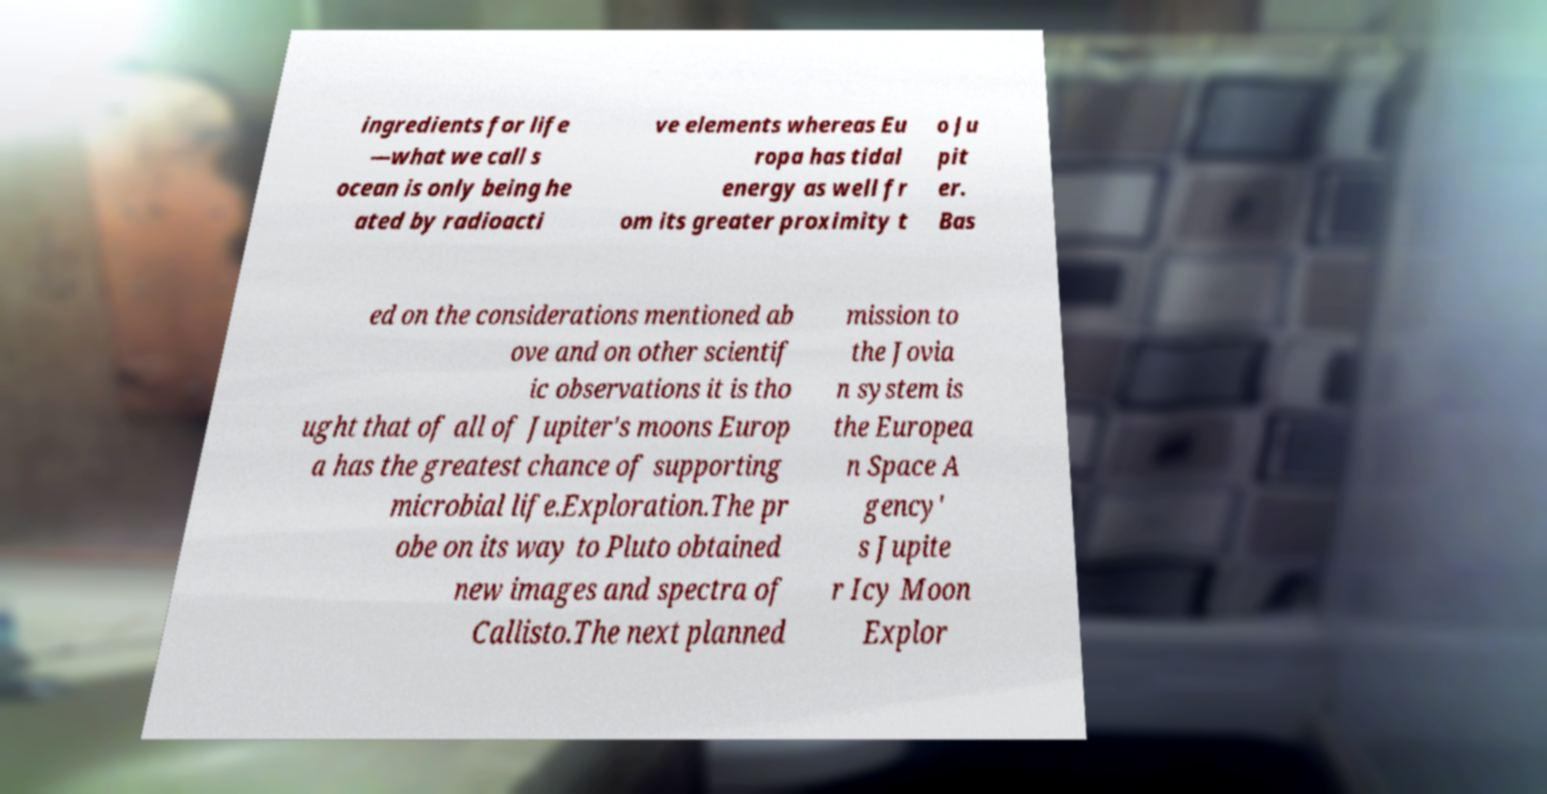There's text embedded in this image that I need extracted. Can you transcribe it verbatim? ingredients for life —what we call s ocean is only being he ated by radioacti ve elements whereas Eu ropa has tidal energy as well fr om its greater proximity t o Ju pit er. Bas ed on the considerations mentioned ab ove and on other scientif ic observations it is tho ught that of all of Jupiter's moons Europ a has the greatest chance of supporting microbial life.Exploration.The pr obe on its way to Pluto obtained new images and spectra of Callisto.The next planned mission to the Jovia n system is the Europea n Space A gency' s Jupite r Icy Moon Explor 